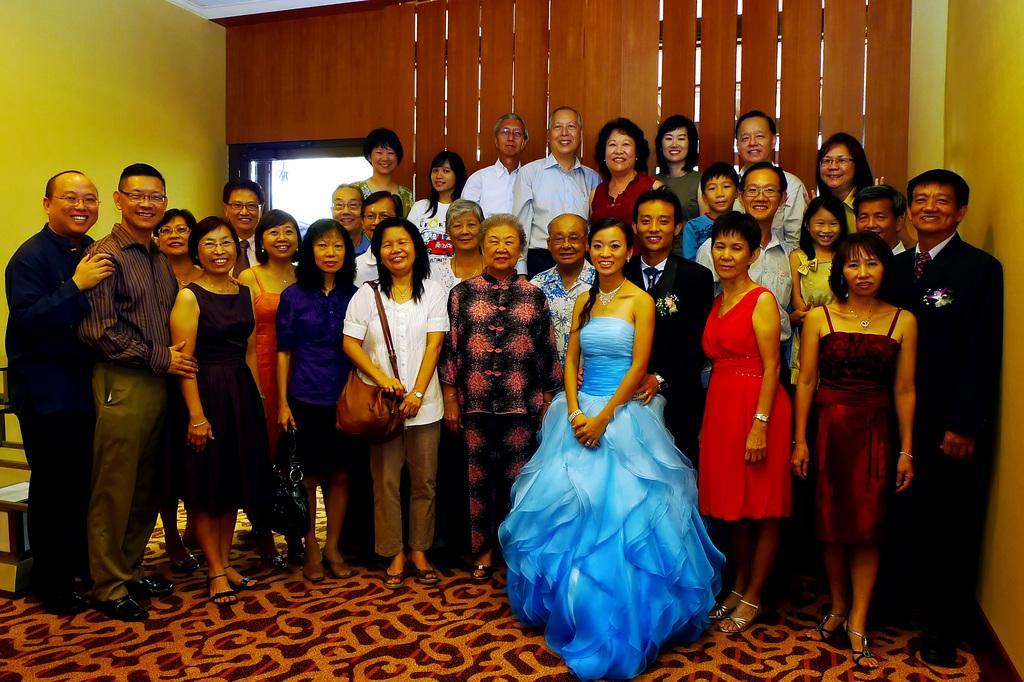What can be seen in the image? There are people standing in the image. What is beneath the people in the image? There is a floor in the image. What is visible in the background of the image? There is a wall in the background of the image. What feature is present on the wall? There is a door in the wall. What is the price of the protest happening in the image? There is no protest present in the image, and therefore no price can be associated with it. 